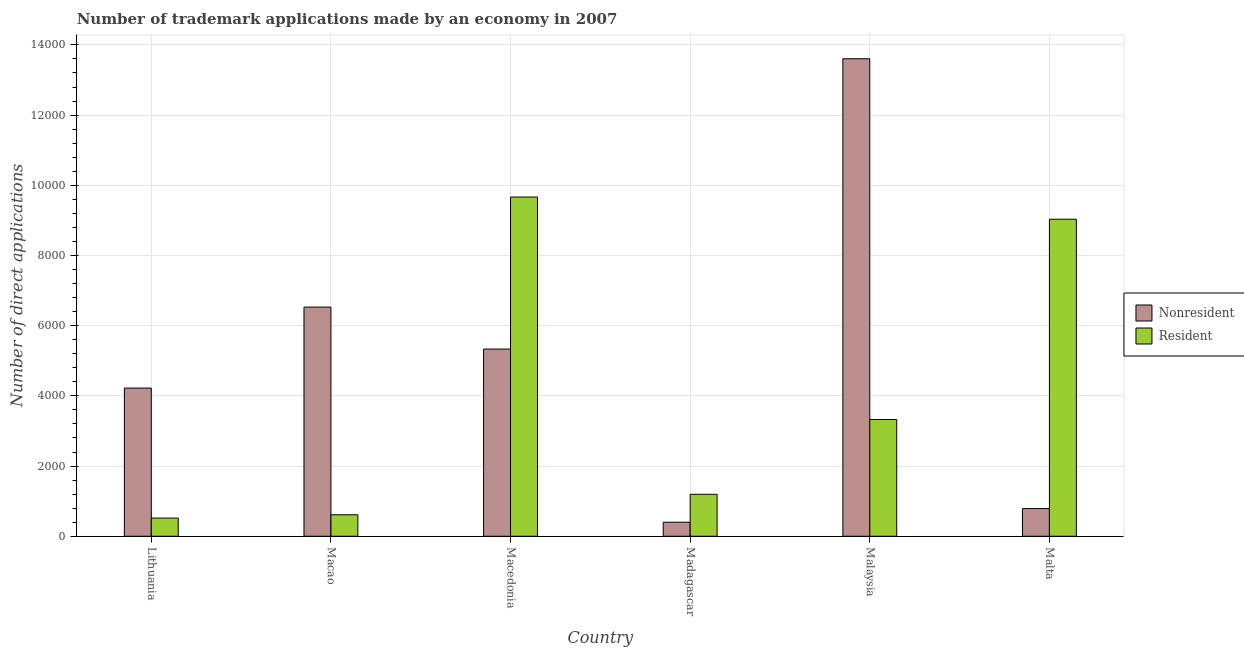How many bars are there on the 5th tick from the left?
Your answer should be very brief. 2. What is the label of the 2nd group of bars from the left?
Provide a succinct answer. Macao. In how many cases, is the number of bars for a given country not equal to the number of legend labels?
Offer a terse response. 0. What is the number of trademark applications made by non residents in Macedonia?
Keep it short and to the point. 5333. Across all countries, what is the maximum number of trademark applications made by residents?
Offer a very short reply. 9665. Across all countries, what is the minimum number of trademark applications made by non residents?
Your answer should be very brief. 400. In which country was the number of trademark applications made by non residents maximum?
Give a very brief answer. Malaysia. In which country was the number of trademark applications made by non residents minimum?
Keep it short and to the point. Madagascar. What is the total number of trademark applications made by non residents in the graph?
Offer a very short reply. 3.09e+04. What is the difference between the number of trademark applications made by residents in Macao and that in Madagascar?
Offer a terse response. -583. What is the difference between the number of trademark applications made by non residents in Macao and the number of trademark applications made by residents in Macedonia?
Provide a short and direct response. -3136. What is the average number of trademark applications made by residents per country?
Give a very brief answer. 4058.17. What is the difference between the number of trademark applications made by residents and number of trademark applications made by non residents in Malaysia?
Provide a short and direct response. -1.03e+04. What is the ratio of the number of trademark applications made by residents in Lithuania to that in Madagascar?
Provide a succinct answer. 0.43. Is the difference between the number of trademark applications made by residents in Lithuania and Macedonia greater than the difference between the number of trademark applications made by non residents in Lithuania and Macedonia?
Make the answer very short. No. What is the difference between the highest and the second highest number of trademark applications made by non residents?
Offer a very short reply. 7076. What is the difference between the highest and the lowest number of trademark applications made by residents?
Keep it short and to the point. 9147. In how many countries, is the number of trademark applications made by non residents greater than the average number of trademark applications made by non residents taken over all countries?
Your answer should be very brief. 3. What does the 1st bar from the left in Macedonia represents?
Keep it short and to the point. Nonresident. What does the 2nd bar from the right in Lithuania represents?
Make the answer very short. Nonresident. How many bars are there?
Offer a very short reply. 12. Are all the bars in the graph horizontal?
Provide a succinct answer. No. How many countries are there in the graph?
Ensure brevity in your answer.  6. What is the difference between two consecutive major ticks on the Y-axis?
Offer a very short reply. 2000. Does the graph contain grids?
Keep it short and to the point. Yes. How many legend labels are there?
Provide a short and direct response. 2. How are the legend labels stacked?
Give a very brief answer. Vertical. What is the title of the graph?
Provide a succinct answer. Number of trademark applications made by an economy in 2007. Does "2012 US$" appear as one of the legend labels in the graph?
Your answer should be compact. No. What is the label or title of the X-axis?
Provide a succinct answer. Country. What is the label or title of the Y-axis?
Ensure brevity in your answer.  Number of direct applications. What is the Number of direct applications in Nonresident in Lithuania?
Provide a short and direct response. 4222. What is the Number of direct applications in Resident in Lithuania?
Ensure brevity in your answer.  518. What is the Number of direct applications in Nonresident in Macao?
Provide a succinct answer. 6529. What is the Number of direct applications of Resident in Macao?
Provide a short and direct response. 612. What is the Number of direct applications in Nonresident in Macedonia?
Provide a short and direct response. 5333. What is the Number of direct applications in Resident in Macedonia?
Your answer should be very brief. 9665. What is the Number of direct applications of Resident in Madagascar?
Your answer should be very brief. 1195. What is the Number of direct applications in Nonresident in Malaysia?
Ensure brevity in your answer.  1.36e+04. What is the Number of direct applications in Resident in Malaysia?
Ensure brevity in your answer.  3326. What is the Number of direct applications of Nonresident in Malta?
Offer a very short reply. 788. What is the Number of direct applications in Resident in Malta?
Your response must be concise. 9033. Across all countries, what is the maximum Number of direct applications of Nonresident?
Your answer should be very brief. 1.36e+04. Across all countries, what is the maximum Number of direct applications in Resident?
Ensure brevity in your answer.  9665. Across all countries, what is the minimum Number of direct applications in Resident?
Offer a terse response. 518. What is the total Number of direct applications in Nonresident in the graph?
Offer a terse response. 3.09e+04. What is the total Number of direct applications in Resident in the graph?
Your answer should be compact. 2.43e+04. What is the difference between the Number of direct applications in Nonresident in Lithuania and that in Macao?
Offer a very short reply. -2307. What is the difference between the Number of direct applications in Resident in Lithuania and that in Macao?
Keep it short and to the point. -94. What is the difference between the Number of direct applications in Nonresident in Lithuania and that in Macedonia?
Provide a short and direct response. -1111. What is the difference between the Number of direct applications of Resident in Lithuania and that in Macedonia?
Your answer should be compact. -9147. What is the difference between the Number of direct applications in Nonresident in Lithuania and that in Madagascar?
Make the answer very short. 3822. What is the difference between the Number of direct applications of Resident in Lithuania and that in Madagascar?
Make the answer very short. -677. What is the difference between the Number of direct applications in Nonresident in Lithuania and that in Malaysia?
Your response must be concise. -9383. What is the difference between the Number of direct applications in Resident in Lithuania and that in Malaysia?
Give a very brief answer. -2808. What is the difference between the Number of direct applications of Nonresident in Lithuania and that in Malta?
Your answer should be very brief. 3434. What is the difference between the Number of direct applications in Resident in Lithuania and that in Malta?
Give a very brief answer. -8515. What is the difference between the Number of direct applications of Nonresident in Macao and that in Macedonia?
Your response must be concise. 1196. What is the difference between the Number of direct applications of Resident in Macao and that in Macedonia?
Make the answer very short. -9053. What is the difference between the Number of direct applications of Nonresident in Macao and that in Madagascar?
Your response must be concise. 6129. What is the difference between the Number of direct applications in Resident in Macao and that in Madagascar?
Your response must be concise. -583. What is the difference between the Number of direct applications of Nonresident in Macao and that in Malaysia?
Offer a very short reply. -7076. What is the difference between the Number of direct applications of Resident in Macao and that in Malaysia?
Make the answer very short. -2714. What is the difference between the Number of direct applications in Nonresident in Macao and that in Malta?
Keep it short and to the point. 5741. What is the difference between the Number of direct applications of Resident in Macao and that in Malta?
Keep it short and to the point. -8421. What is the difference between the Number of direct applications of Nonresident in Macedonia and that in Madagascar?
Offer a very short reply. 4933. What is the difference between the Number of direct applications of Resident in Macedonia and that in Madagascar?
Provide a succinct answer. 8470. What is the difference between the Number of direct applications of Nonresident in Macedonia and that in Malaysia?
Your response must be concise. -8272. What is the difference between the Number of direct applications of Resident in Macedonia and that in Malaysia?
Make the answer very short. 6339. What is the difference between the Number of direct applications of Nonresident in Macedonia and that in Malta?
Offer a terse response. 4545. What is the difference between the Number of direct applications of Resident in Macedonia and that in Malta?
Provide a short and direct response. 632. What is the difference between the Number of direct applications of Nonresident in Madagascar and that in Malaysia?
Keep it short and to the point. -1.32e+04. What is the difference between the Number of direct applications in Resident in Madagascar and that in Malaysia?
Provide a succinct answer. -2131. What is the difference between the Number of direct applications of Nonresident in Madagascar and that in Malta?
Make the answer very short. -388. What is the difference between the Number of direct applications of Resident in Madagascar and that in Malta?
Provide a succinct answer. -7838. What is the difference between the Number of direct applications in Nonresident in Malaysia and that in Malta?
Make the answer very short. 1.28e+04. What is the difference between the Number of direct applications in Resident in Malaysia and that in Malta?
Offer a terse response. -5707. What is the difference between the Number of direct applications in Nonresident in Lithuania and the Number of direct applications in Resident in Macao?
Your answer should be compact. 3610. What is the difference between the Number of direct applications in Nonresident in Lithuania and the Number of direct applications in Resident in Macedonia?
Keep it short and to the point. -5443. What is the difference between the Number of direct applications of Nonresident in Lithuania and the Number of direct applications of Resident in Madagascar?
Offer a very short reply. 3027. What is the difference between the Number of direct applications in Nonresident in Lithuania and the Number of direct applications in Resident in Malaysia?
Offer a terse response. 896. What is the difference between the Number of direct applications in Nonresident in Lithuania and the Number of direct applications in Resident in Malta?
Keep it short and to the point. -4811. What is the difference between the Number of direct applications in Nonresident in Macao and the Number of direct applications in Resident in Macedonia?
Provide a succinct answer. -3136. What is the difference between the Number of direct applications of Nonresident in Macao and the Number of direct applications of Resident in Madagascar?
Give a very brief answer. 5334. What is the difference between the Number of direct applications of Nonresident in Macao and the Number of direct applications of Resident in Malaysia?
Your answer should be compact. 3203. What is the difference between the Number of direct applications in Nonresident in Macao and the Number of direct applications in Resident in Malta?
Your answer should be compact. -2504. What is the difference between the Number of direct applications of Nonresident in Macedonia and the Number of direct applications of Resident in Madagascar?
Provide a short and direct response. 4138. What is the difference between the Number of direct applications in Nonresident in Macedonia and the Number of direct applications in Resident in Malaysia?
Offer a terse response. 2007. What is the difference between the Number of direct applications of Nonresident in Macedonia and the Number of direct applications of Resident in Malta?
Your answer should be very brief. -3700. What is the difference between the Number of direct applications of Nonresident in Madagascar and the Number of direct applications of Resident in Malaysia?
Ensure brevity in your answer.  -2926. What is the difference between the Number of direct applications of Nonresident in Madagascar and the Number of direct applications of Resident in Malta?
Provide a succinct answer. -8633. What is the difference between the Number of direct applications of Nonresident in Malaysia and the Number of direct applications of Resident in Malta?
Your answer should be very brief. 4572. What is the average Number of direct applications of Nonresident per country?
Provide a succinct answer. 5146.17. What is the average Number of direct applications in Resident per country?
Ensure brevity in your answer.  4058.17. What is the difference between the Number of direct applications of Nonresident and Number of direct applications of Resident in Lithuania?
Ensure brevity in your answer.  3704. What is the difference between the Number of direct applications in Nonresident and Number of direct applications in Resident in Macao?
Your answer should be compact. 5917. What is the difference between the Number of direct applications in Nonresident and Number of direct applications in Resident in Macedonia?
Ensure brevity in your answer.  -4332. What is the difference between the Number of direct applications in Nonresident and Number of direct applications in Resident in Madagascar?
Provide a short and direct response. -795. What is the difference between the Number of direct applications of Nonresident and Number of direct applications of Resident in Malaysia?
Provide a short and direct response. 1.03e+04. What is the difference between the Number of direct applications of Nonresident and Number of direct applications of Resident in Malta?
Your response must be concise. -8245. What is the ratio of the Number of direct applications in Nonresident in Lithuania to that in Macao?
Make the answer very short. 0.65. What is the ratio of the Number of direct applications of Resident in Lithuania to that in Macao?
Offer a very short reply. 0.85. What is the ratio of the Number of direct applications in Nonresident in Lithuania to that in Macedonia?
Keep it short and to the point. 0.79. What is the ratio of the Number of direct applications of Resident in Lithuania to that in Macedonia?
Make the answer very short. 0.05. What is the ratio of the Number of direct applications of Nonresident in Lithuania to that in Madagascar?
Ensure brevity in your answer.  10.55. What is the ratio of the Number of direct applications in Resident in Lithuania to that in Madagascar?
Your response must be concise. 0.43. What is the ratio of the Number of direct applications in Nonresident in Lithuania to that in Malaysia?
Your answer should be very brief. 0.31. What is the ratio of the Number of direct applications of Resident in Lithuania to that in Malaysia?
Make the answer very short. 0.16. What is the ratio of the Number of direct applications of Nonresident in Lithuania to that in Malta?
Your response must be concise. 5.36. What is the ratio of the Number of direct applications in Resident in Lithuania to that in Malta?
Make the answer very short. 0.06. What is the ratio of the Number of direct applications of Nonresident in Macao to that in Macedonia?
Provide a succinct answer. 1.22. What is the ratio of the Number of direct applications of Resident in Macao to that in Macedonia?
Keep it short and to the point. 0.06. What is the ratio of the Number of direct applications of Nonresident in Macao to that in Madagascar?
Provide a short and direct response. 16.32. What is the ratio of the Number of direct applications in Resident in Macao to that in Madagascar?
Offer a terse response. 0.51. What is the ratio of the Number of direct applications in Nonresident in Macao to that in Malaysia?
Make the answer very short. 0.48. What is the ratio of the Number of direct applications of Resident in Macao to that in Malaysia?
Provide a short and direct response. 0.18. What is the ratio of the Number of direct applications of Nonresident in Macao to that in Malta?
Your answer should be compact. 8.29. What is the ratio of the Number of direct applications of Resident in Macao to that in Malta?
Provide a succinct answer. 0.07. What is the ratio of the Number of direct applications of Nonresident in Macedonia to that in Madagascar?
Ensure brevity in your answer.  13.33. What is the ratio of the Number of direct applications of Resident in Macedonia to that in Madagascar?
Keep it short and to the point. 8.09. What is the ratio of the Number of direct applications in Nonresident in Macedonia to that in Malaysia?
Keep it short and to the point. 0.39. What is the ratio of the Number of direct applications in Resident in Macedonia to that in Malaysia?
Provide a succinct answer. 2.91. What is the ratio of the Number of direct applications in Nonresident in Macedonia to that in Malta?
Provide a succinct answer. 6.77. What is the ratio of the Number of direct applications of Resident in Macedonia to that in Malta?
Offer a terse response. 1.07. What is the ratio of the Number of direct applications of Nonresident in Madagascar to that in Malaysia?
Offer a very short reply. 0.03. What is the ratio of the Number of direct applications in Resident in Madagascar to that in Malaysia?
Offer a very short reply. 0.36. What is the ratio of the Number of direct applications of Nonresident in Madagascar to that in Malta?
Offer a very short reply. 0.51. What is the ratio of the Number of direct applications of Resident in Madagascar to that in Malta?
Make the answer very short. 0.13. What is the ratio of the Number of direct applications in Nonresident in Malaysia to that in Malta?
Keep it short and to the point. 17.27. What is the ratio of the Number of direct applications of Resident in Malaysia to that in Malta?
Provide a short and direct response. 0.37. What is the difference between the highest and the second highest Number of direct applications in Nonresident?
Your answer should be very brief. 7076. What is the difference between the highest and the second highest Number of direct applications in Resident?
Your answer should be compact. 632. What is the difference between the highest and the lowest Number of direct applications of Nonresident?
Your answer should be very brief. 1.32e+04. What is the difference between the highest and the lowest Number of direct applications of Resident?
Offer a terse response. 9147. 